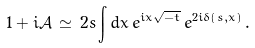<formula> <loc_0><loc_0><loc_500><loc_500>1 + i \mathcal { A } \, \simeq \, 2 s \int d x \, e ^ { i x \sqrt { - t } } \, e ^ { 2 i \delta \left ( s , x \right ) } \, .</formula> 